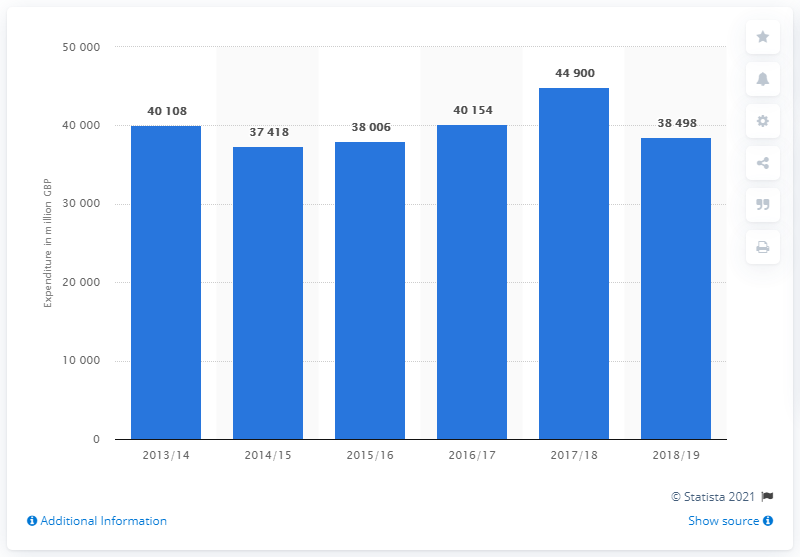Indicate a few pertinent items in this graphic. The peak expenditure on debt interest in the 2017/18 fiscal year was 44,900. 